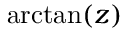<formula> <loc_0><loc_0><loc_500><loc_500>\arctan ( z )</formula> 